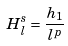Convert formula to latex. <formula><loc_0><loc_0><loc_500><loc_500>H ^ { s } _ { l } = \frac { h _ { 1 } } { l ^ { p } }</formula> 